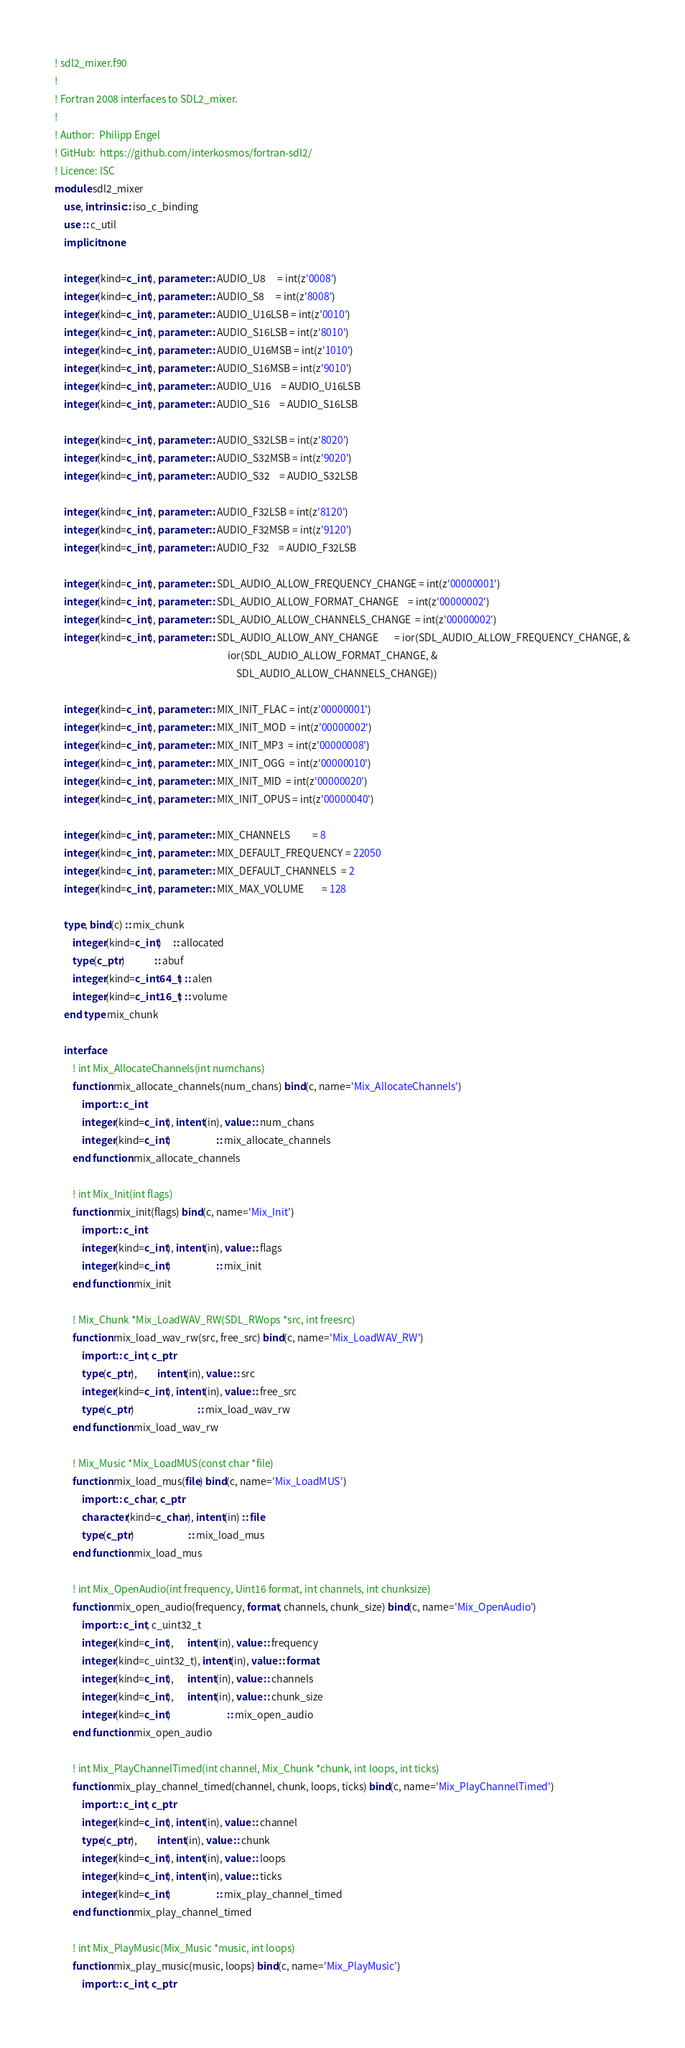<code> <loc_0><loc_0><loc_500><loc_500><_FORTRAN_>! sdl2_mixer.f90
!
! Fortran 2008 interfaces to SDL2_mixer.
!
! Author:  Philipp Engel
! GitHub:  https://github.com/interkosmos/fortran-sdl2/
! Licence: ISC
module sdl2_mixer
    use, intrinsic :: iso_c_binding
    use :: c_util
    implicit none

    integer(kind=c_int), parameter :: AUDIO_U8     = int(z'0008')
    integer(kind=c_int), parameter :: AUDIO_S8     = int(z'8008')
    integer(kind=c_int), parameter :: AUDIO_U16LSB = int(z'0010')
    integer(kind=c_int), parameter :: AUDIO_S16LSB = int(z'8010')
    integer(kind=c_int), parameter :: AUDIO_U16MSB = int(z'1010')
    integer(kind=c_int), parameter :: AUDIO_S16MSB = int(z'9010')
    integer(kind=c_int), parameter :: AUDIO_U16    = AUDIO_U16LSB
    integer(kind=c_int), parameter :: AUDIO_S16    = AUDIO_S16LSB

    integer(kind=c_int), parameter :: AUDIO_S32LSB = int(z'8020')
    integer(kind=c_int), parameter :: AUDIO_S32MSB = int(z'9020')
    integer(kind=c_int), parameter :: AUDIO_S32    = AUDIO_S32LSB

    integer(kind=c_int), parameter :: AUDIO_F32LSB = int(z'8120')
    integer(kind=c_int), parameter :: AUDIO_F32MSB = int(z'9120')
    integer(kind=c_int), parameter :: AUDIO_F32    = AUDIO_F32LSB

    integer(kind=c_int), parameter :: SDL_AUDIO_ALLOW_FREQUENCY_CHANGE = int(z'00000001')
    integer(kind=c_int), parameter :: SDL_AUDIO_ALLOW_FORMAT_CHANGE    = int(z'00000002')
    integer(kind=c_int), parameter :: SDL_AUDIO_ALLOW_CHANNELS_CHANGE  = int(z'00000002')
    integer(kind=c_int), parameter :: SDL_AUDIO_ALLOW_ANY_CHANGE       = ior(SDL_AUDIO_ALLOW_FREQUENCY_CHANGE, &
                                                                             ior(SDL_AUDIO_ALLOW_FORMAT_CHANGE, &
                                                                                 SDL_AUDIO_ALLOW_CHANNELS_CHANGE))

    integer(kind=c_int), parameter :: MIX_INIT_FLAC = int(z'00000001')
    integer(kind=c_int), parameter :: MIX_INIT_MOD  = int(z'00000002')
    integer(kind=c_int), parameter :: MIX_INIT_MP3  = int(z'00000008')
    integer(kind=c_int), parameter :: MIX_INIT_OGG  = int(z'00000010')
    integer(kind=c_int), parameter :: MIX_INIT_MID  = int(z'00000020')
    integer(kind=c_int), parameter :: MIX_INIT_OPUS = int(z'00000040')

    integer(kind=c_int), parameter :: MIX_CHANNELS          = 8
    integer(kind=c_int), parameter :: MIX_DEFAULT_FREQUENCY = 22050
    integer(kind=c_int), parameter :: MIX_DEFAULT_CHANNELS  = 2
    integer(kind=c_int), parameter :: MIX_MAX_VOLUME        = 128

    type, bind(c) :: mix_chunk
        integer(kind=c_int)     :: allocated
        type(c_ptr)             :: abuf
        integer(kind=c_int64_t) :: alen
        integer(kind=c_int16_t) :: volume
    end type mix_chunk

    interface
        ! int Mix_AllocateChannels(int numchans)
        function mix_allocate_channels(num_chans) bind(c, name='Mix_AllocateChannels')
            import :: c_int
            integer(kind=c_int), intent(in), value :: num_chans
            integer(kind=c_int)                    :: mix_allocate_channels
        end function mix_allocate_channels

        ! int Mix_Init(int flags)
        function mix_init(flags) bind(c, name='Mix_Init')
            import :: c_int
            integer(kind=c_int), intent(in), value :: flags
            integer(kind=c_int)                    :: mix_init
        end function mix_init

        ! Mix_Chunk *Mix_LoadWAV_RW(SDL_RWops *src, int freesrc)
        function mix_load_wav_rw(src, free_src) bind(c, name='Mix_LoadWAV_RW')
            import :: c_int, c_ptr
            type(c_ptr),         intent(in), value :: src
            integer(kind=c_int), intent(in), value :: free_src
            type(c_ptr)                            :: mix_load_wav_rw
        end function mix_load_wav_rw

        ! Mix_Music *Mix_LoadMUS(const char *file)
        function mix_load_mus(file) bind(c, name='Mix_LoadMUS')
            import :: c_char, c_ptr
            character(kind=c_char), intent(in) :: file
            type(c_ptr)                        :: mix_load_mus
        end function mix_load_mus

        ! int Mix_OpenAudio(int frequency, Uint16 format, int channels, int chunksize)
        function mix_open_audio(frequency, format, channels, chunk_size) bind(c, name='Mix_OpenAudio')
            import :: c_int, c_uint32_t
            integer(kind=c_int),      intent(in), value :: frequency
            integer(kind=c_uint32_t), intent(in), value :: format
            integer(kind=c_int),      intent(in), value :: channels
            integer(kind=c_int),      intent(in), value :: chunk_size
            integer(kind=c_int)                         :: mix_open_audio
        end function mix_open_audio

        ! int Mix_PlayChannelTimed(int channel, Mix_Chunk *chunk, int loops, int ticks)
        function mix_play_channel_timed(channel, chunk, loops, ticks) bind(c, name='Mix_PlayChannelTimed')
            import :: c_int, c_ptr
            integer(kind=c_int), intent(in), value :: channel
            type(c_ptr),         intent(in), value :: chunk
            integer(kind=c_int), intent(in), value :: loops
            integer(kind=c_int), intent(in), value :: ticks
            integer(kind=c_int)                    :: mix_play_channel_timed
        end function mix_play_channel_timed

        ! int Mix_PlayMusic(Mix_Music *music, int loops)
        function mix_play_music(music, loops) bind(c, name='Mix_PlayMusic')
            import :: c_int, c_ptr</code> 